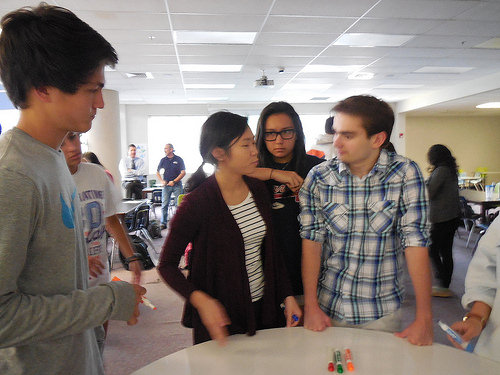<image>
Can you confirm if the marker is on the table? Yes. Looking at the image, I can see the marker is positioned on top of the table, with the table providing support. 